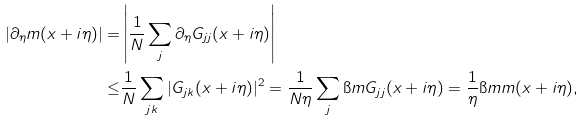Convert formula to latex. <formula><loc_0><loc_0><loc_500><loc_500>| \partial _ { \eta } m ( x + i \eta ) | = & \left | \frac { 1 } { N } \sum _ { j } \partial _ { \eta } G _ { j j } ( x + i \eta ) \right | \\ \leq & \frac { 1 } { N } \sum _ { j k } | G _ { j k } ( x + i \eta ) | ^ { 2 } = \frac { 1 } { N \eta } \sum _ { j } \i m G _ { j j } ( x + i \eta ) = \frac { 1 } { \eta } \i m m ( x + i \eta ) ,</formula> 